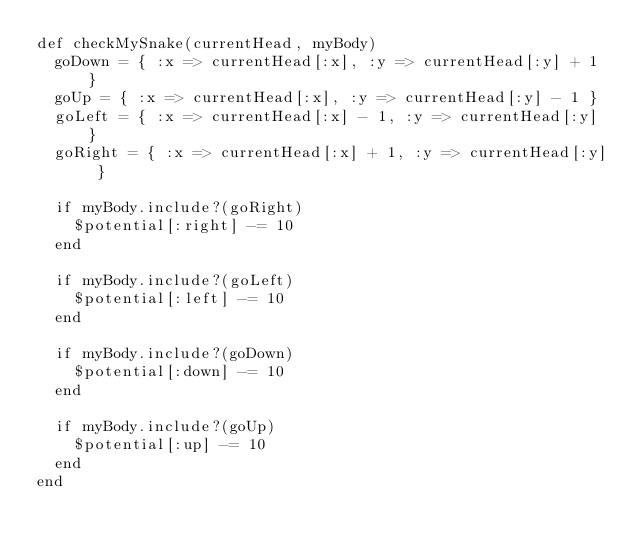Convert code to text. <code><loc_0><loc_0><loc_500><loc_500><_Ruby_>def checkMySnake(currentHead, myBody)
  goDown = { :x => currentHead[:x], :y => currentHead[:y] + 1 }
  goUp = { :x => currentHead[:x], :y => currentHead[:y] - 1 }
  goLeft = { :x => currentHead[:x] - 1, :y => currentHead[:y] }
  goRight = { :x => currentHead[:x] + 1, :y => currentHead[:y] }

  if myBody.include?(goRight)
    $potential[:right] -= 10
  end

  if myBody.include?(goLeft)
    $potential[:left] -= 10
  end

  if myBody.include?(goDown)
    $potential[:down] -= 10
  end

  if myBody.include?(goUp)
    $potential[:up] -= 10
  end
end
</code> 